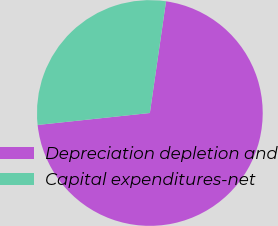Convert chart. <chart><loc_0><loc_0><loc_500><loc_500><pie_chart><fcel>Depreciation depletion and<fcel>Capital expenditures-net<nl><fcel>71.02%<fcel>28.98%<nl></chart> 